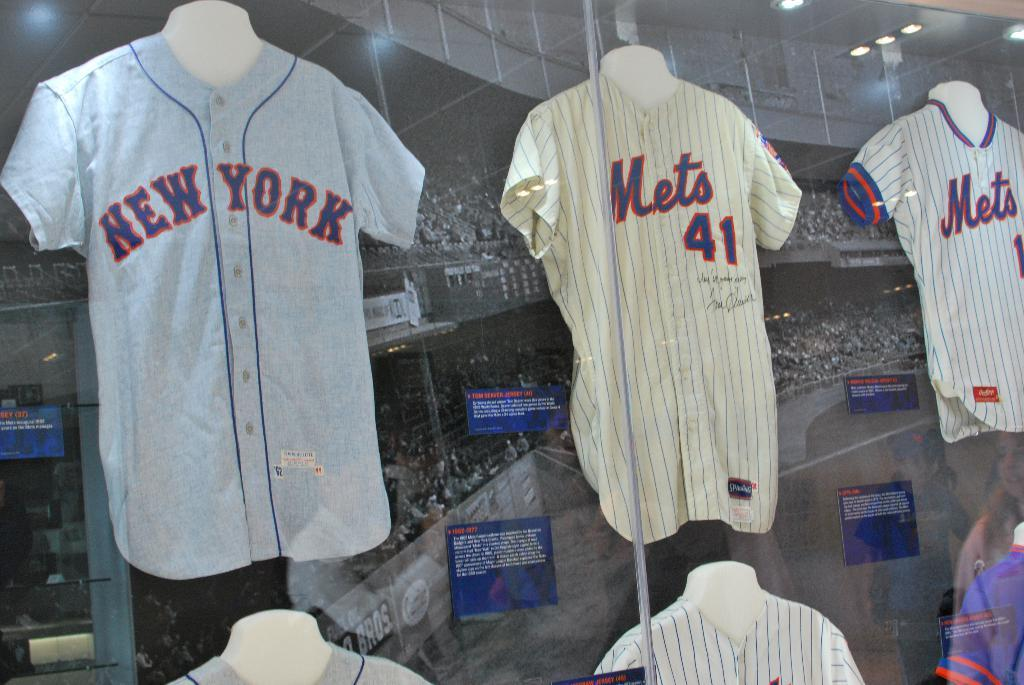Provide a one-sentence caption for the provided image. Display of three New York Mets team jerseys. 